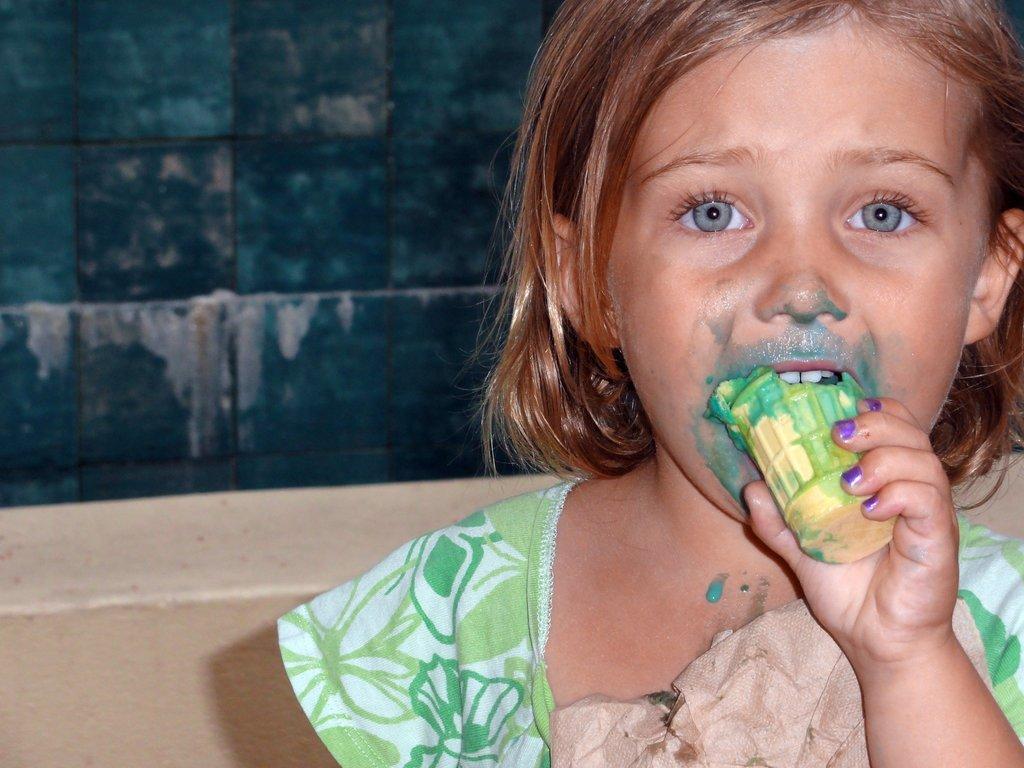In one or two sentences, can you explain what this image depicts? In this image in the front there is a girl eating ice cream. In the background there is a wall which is green in colour. In front of the wall there is an object which is cream in colour. 